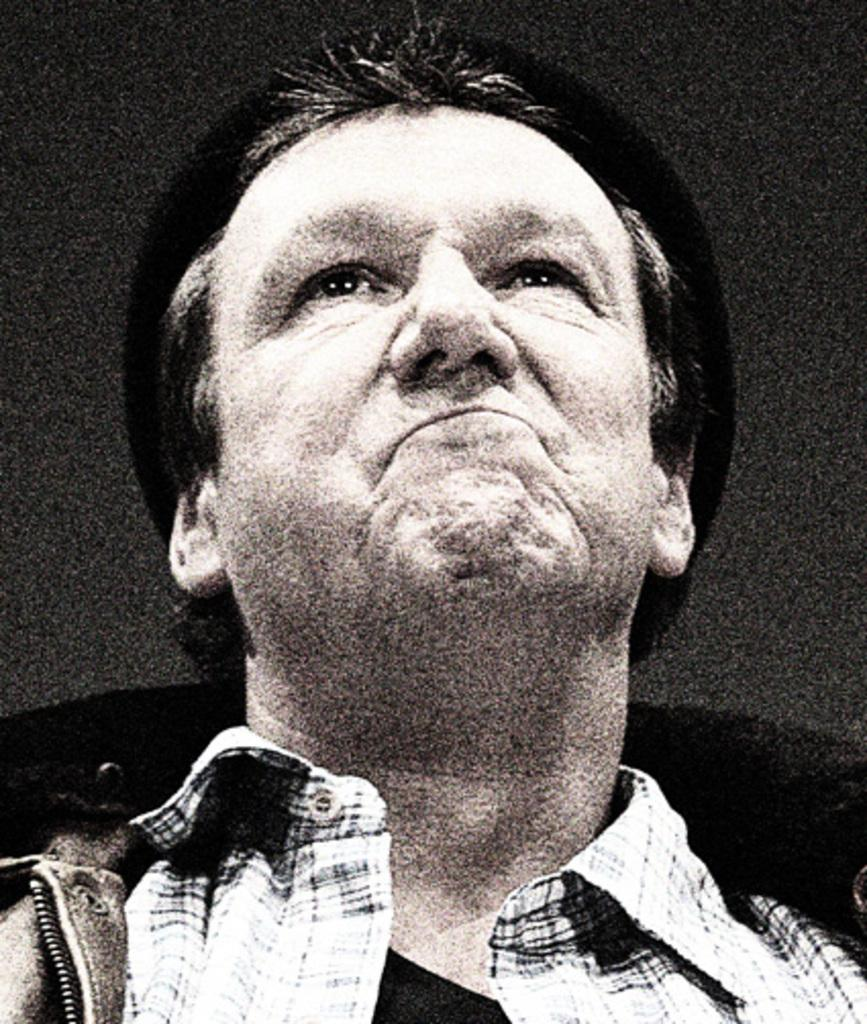Who is present in the image? There is a man in the image. What is the man wearing in the image? The man is wearing a jacket in the image. What type of curtain can be seen in the image? There is no curtain present in the image; it only features a man wearing a jacket. Is there a boat visible in the image? No, there is no boat present in the image. 